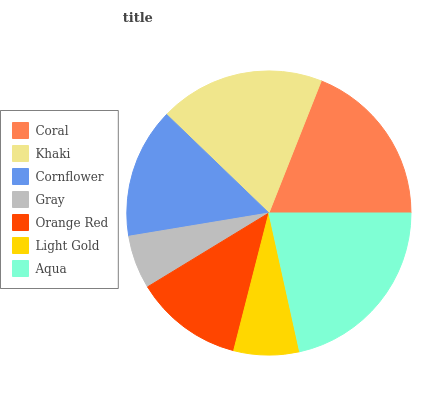Is Gray the minimum?
Answer yes or no. Yes. Is Aqua the maximum?
Answer yes or no. Yes. Is Khaki the minimum?
Answer yes or no. No. Is Khaki the maximum?
Answer yes or no. No. Is Coral greater than Khaki?
Answer yes or no. Yes. Is Khaki less than Coral?
Answer yes or no. Yes. Is Khaki greater than Coral?
Answer yes or no. No. Is Coral less than Khaki?
Answer yes or no. No. Is Cornflower the high median?
Answer yes or no. Yes. Is Cornflower the low median?
Answer yes or no. Yes. Is Orange Red the high median?
Answer yes or no. No. Is Coral the low median?
Answer yes or no. No. 